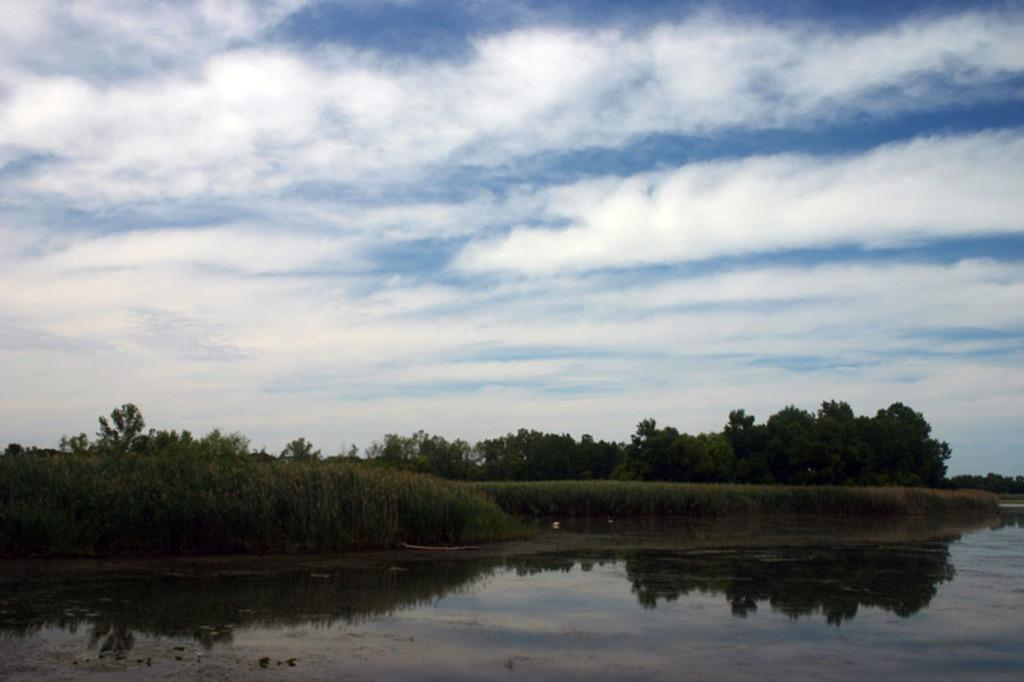What is one of the natural elements present in the image? There is water in the image. What type of vegetation can be seen in the image? There is grass in the image. What can be seen in the distance in the image? There are trees in the background of the image. What is visible above the trees in the image? The sky is visible at the backside of the image. Can you see any lips in the image? There are no lips present in the image. What type of amusement park can be seen in the image? There is no amusement park present in the image. 